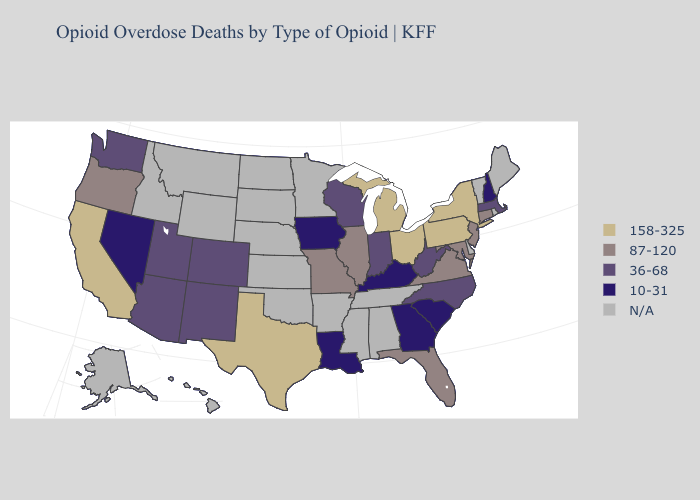What is the value of Vermont?
Answer briefly. N/A. What is the lowest value in states that border Oregon?
Give a very brief answer. 10-31. Does Pennsylvania have the lowest value in the Northeast?
Short answer required. No. Which states have the lowest value in the USA?
Short answer required. Georgia, Iowa, Kentucky, Louisiana, Nevada, New Hampshire, South Carolina. How many symbols are there in the legend?
Keep it brief. 5. Does the first symbol in the legend represent the smallest category?
Answer briefly. No. What is the lowest value in states that border Massachusetts?
Write a very short answer. 10-31. What is the value of Kentucky?
Quick response, please. 10-31. Name the states that have a value in the range 87-120?
Keep it brief. Connecticut, Florida, Illinois, Maryland, Missouri, New Jersey, Oregon, Virginia. Among the states that border Utah , does New Mexico have the highest value?
Concise answer only. Yes. Which states have the highest value in the USA?
Answer briefly. California, Michigan, New York, Ohio, Pennsylvania, Texas. What is the value of Arizona?
Be succinct. 36-68. Name the states that have a value in the range 36-68?
Short answer required. Arizona, Colorado, Indiana, Massachusetts, New Mexico, North Carolina, Utah, Washington, West Virginia, Wisconsin. What is the value of North Carolina?
Quick response, please. 36-68. 